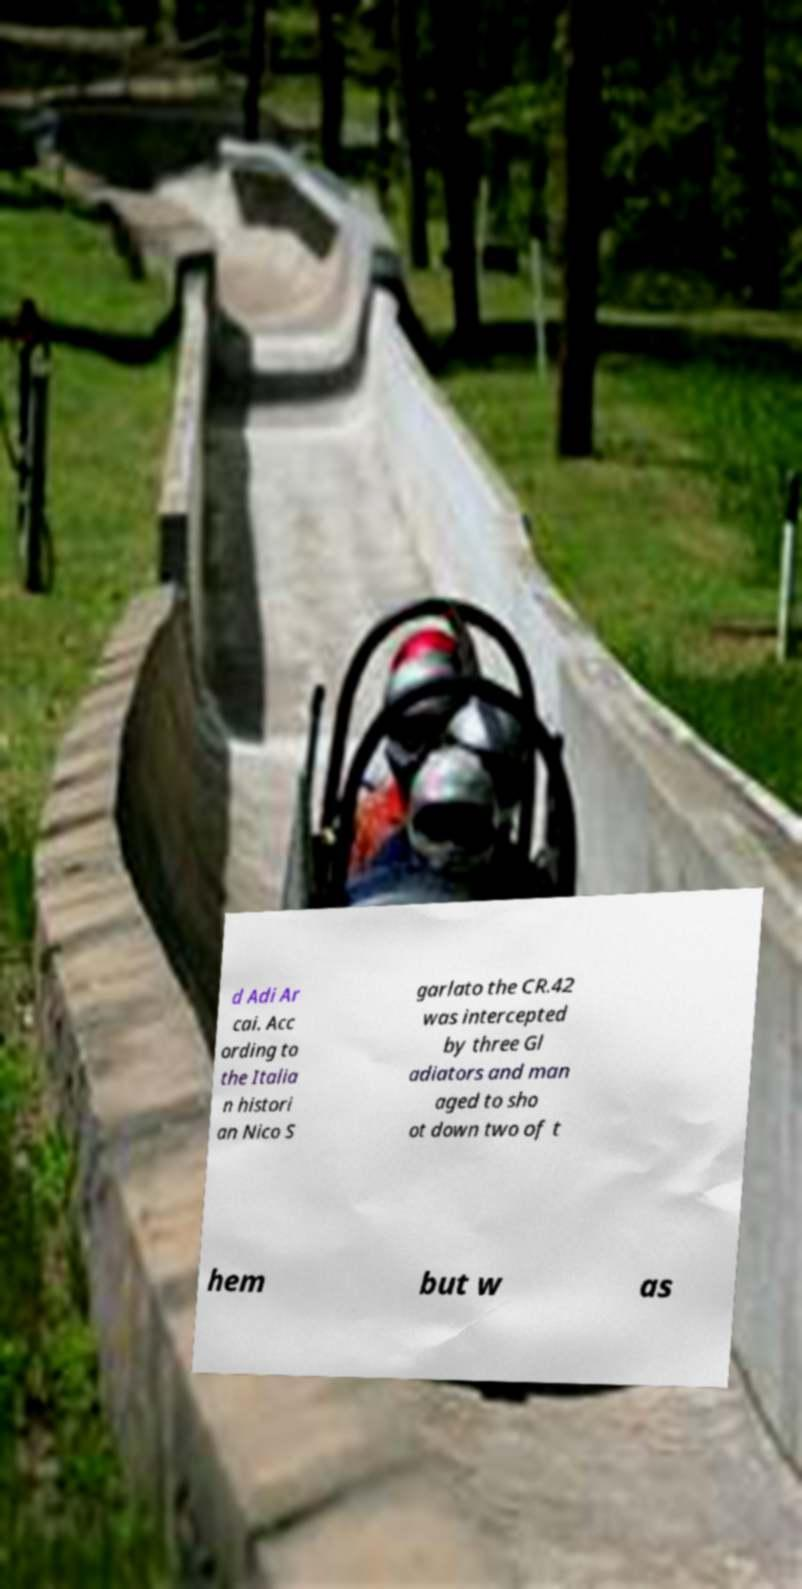Please identify and transcribe the text found in this image. d Adi Ar cai. Acc ording to the Italia n histori an Nico S garlato the CR.42 was intercepted by three Gl adiators and man aged to sho ot down two of t hem but w as 